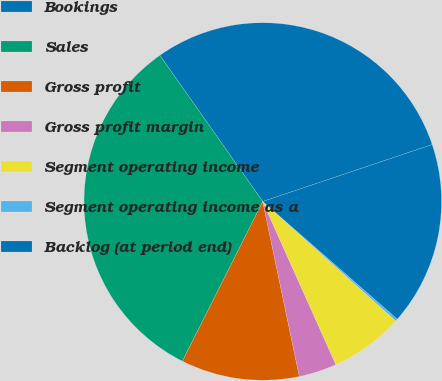Convert chart to OTSL. <chart><loc_0><loc_0><loc_500><loc_500><pie_chart><fcel>Bookings<fcel>Sales<fcel>Gross profit<fcel>Gross profit margin<fcel>Segment operating income<fcel>Segment operating income as a<fcel>Backlog (at period end)<nl><fcel>29.61%<fcel>32.82%<fcel>10.7%<fcel>3.43%<fcel>6.65%<fcel>0.21%<fcel>16.59%<nl></chart> 